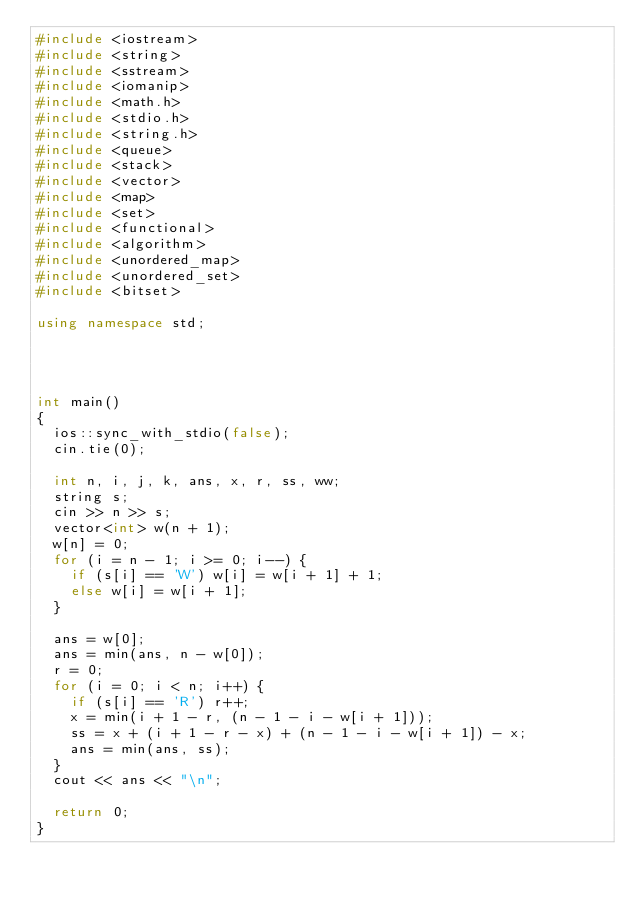<code> <loc_0><loc_0><loc_500><loc_500><_C++_>#include <iostream>
#include <string>
#include <sstream>
#include <iomanip> 
#include <math.h>
#include <stdio.h>
#include <string.h>
#include <queue>
#include <stack>
#include <vector>
#include <map>
#include <set>
#include <functional>
#include <algorithm>
#include <unordered_map>
#include <unordered_set>
#include <bitset>

using namespace std;




int main()
{
	ios::sync_with_stdio(false);
	cin.tie(0);

	int n, i, j, k, ans, x, r, ss, ww;
	string s;
	cin >> n >> s;
	vector<int> w(n + 1);
	w[n] = 0;
	for (i = n - 1; i >= 0; i--) {
		if (s[i] == 'W') w[i] = w[i + 1] + 1;
		else w[i] = w[i + 1];
	}

	ans = w[0];
	ans = min(ans, n - w[0]);
	r = 0;
	for (i = 0; i < n; i++) {
		if (s[i] == 'R') r++;
		x = min(i + 1 - r, (n - 1 - i - w[i + 1]));
		ss = x + (i + 1 - r - x) + (n - 1 - i - w[i + 1]) - x;
		ans = min(ans, ss);
	}
	cout << ans << "\n";

	return 0;
}
</code> 